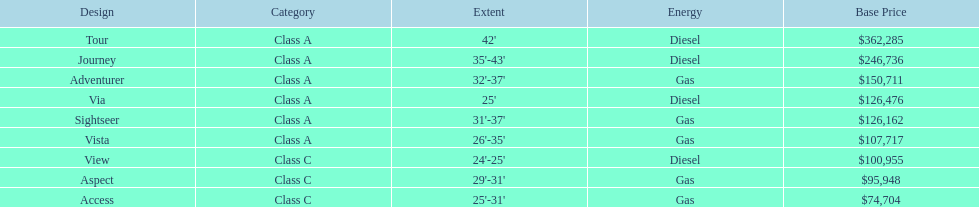Which model has the lowest base price? Access. 